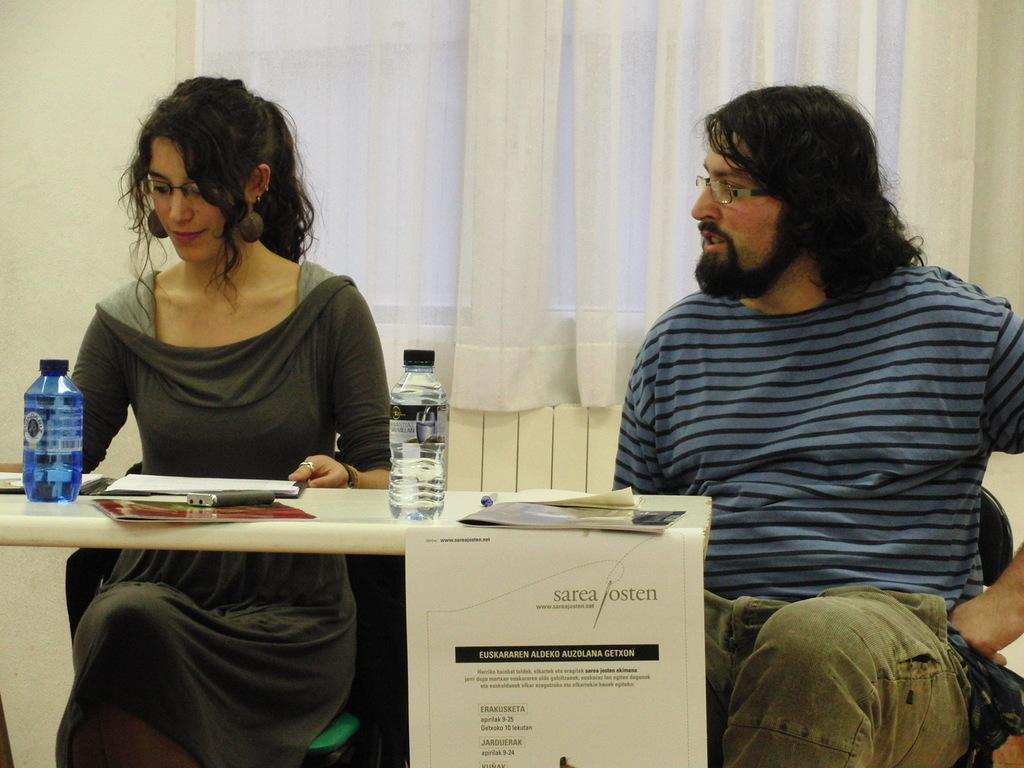How many people are sitting in the image? There are two persons sitting on chairs in the image. What is present on the table in the image? There is a bottle, a paper, and a pen on the table in the image. What can be seen in the background of the image? There is a curtain and a window visible in the background. What type of ear is visible on the table in the image? There is no ear present on the table in the image. What type of grain can be seen growing in the background? There is no grain visible in the image; only a curtain and a window are present in the background. 